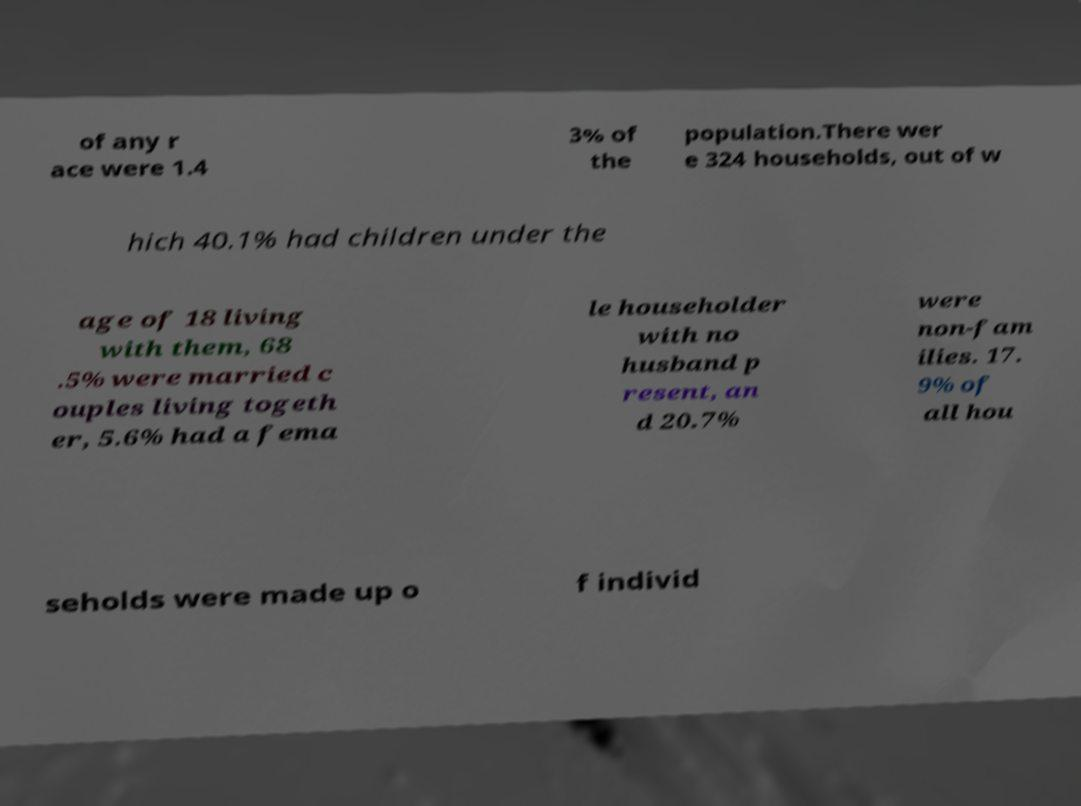Could you assist in decoding the text presented in this image and type it out clearly? of any r ace were 1.4 3% of the population.There wer e 324 households, out of w hich 40.1% had children under the age of 18 living with them, 68 .5% were married c ouples living togeth er, 5.6% had a fema le householder with no husband p resent, an d 20.7% were non-fam ilies. 17. 9% of all hou seholds were made up o f individ 